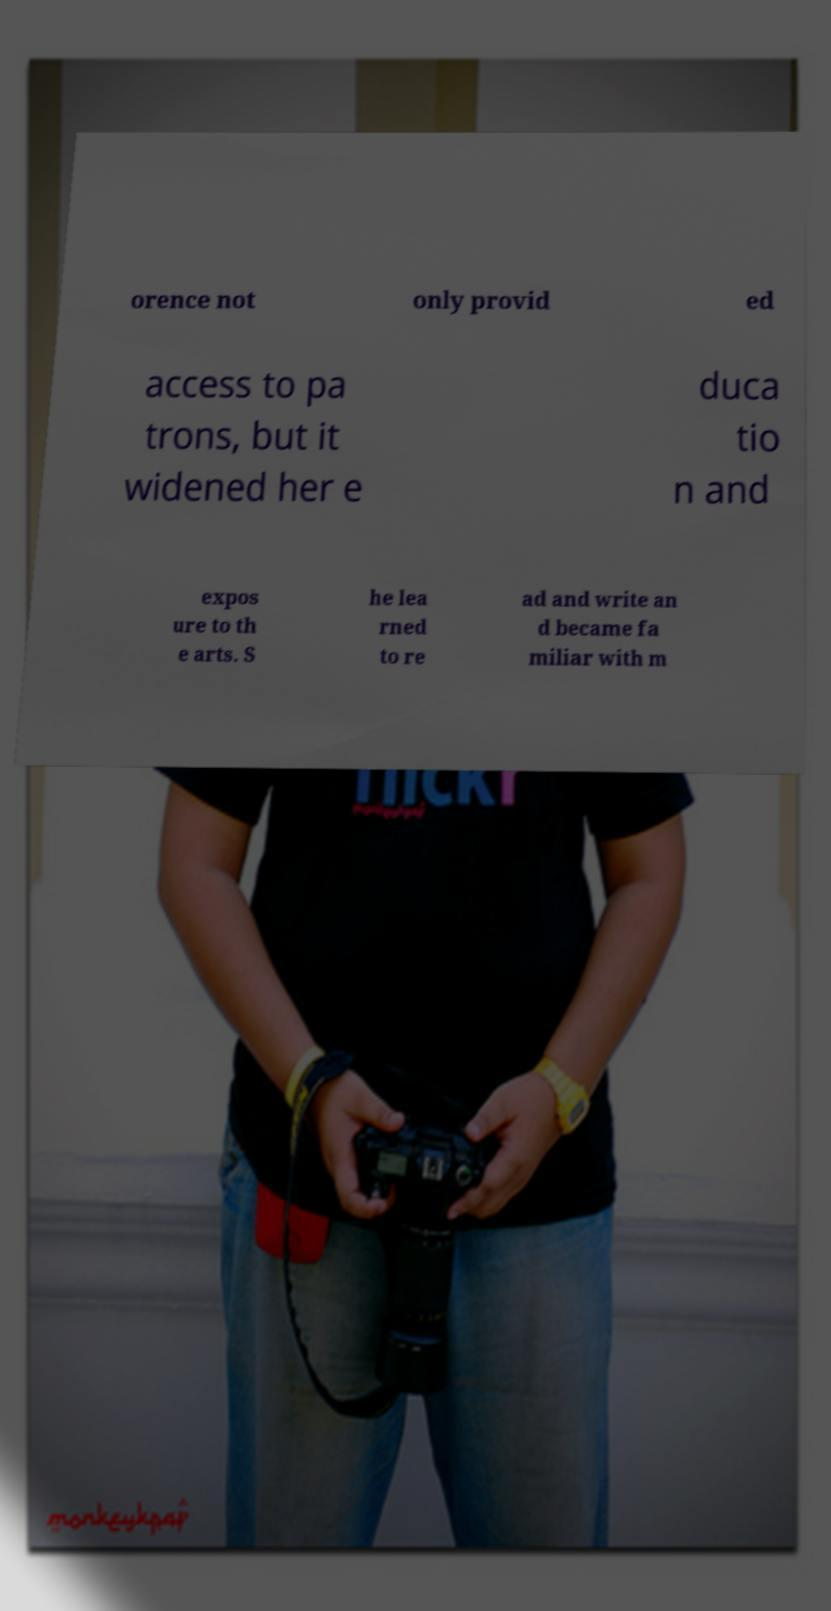Could you extract and type out the text from this image? orence not only provid ed access to pa trons, but it widened her e duca tio n and expos ure to th e arts. S he lea rned to re ad and write an d became fa miliar with m 